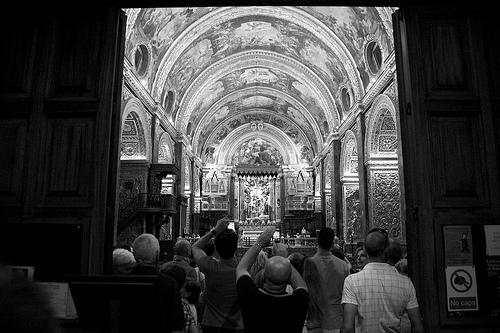Question: when is this picture taken?
Choices:
A. During a concert.
B. Winter.
C. Spring.
D. During tour.
Answer with the letter. Answer: D Question: why is this picture taken?
Choices:
A. Decoration for a home.
B. For keepsakes for family.
C. To put in a frame.
D. Photography.
Answer with the letter. Answer: D 